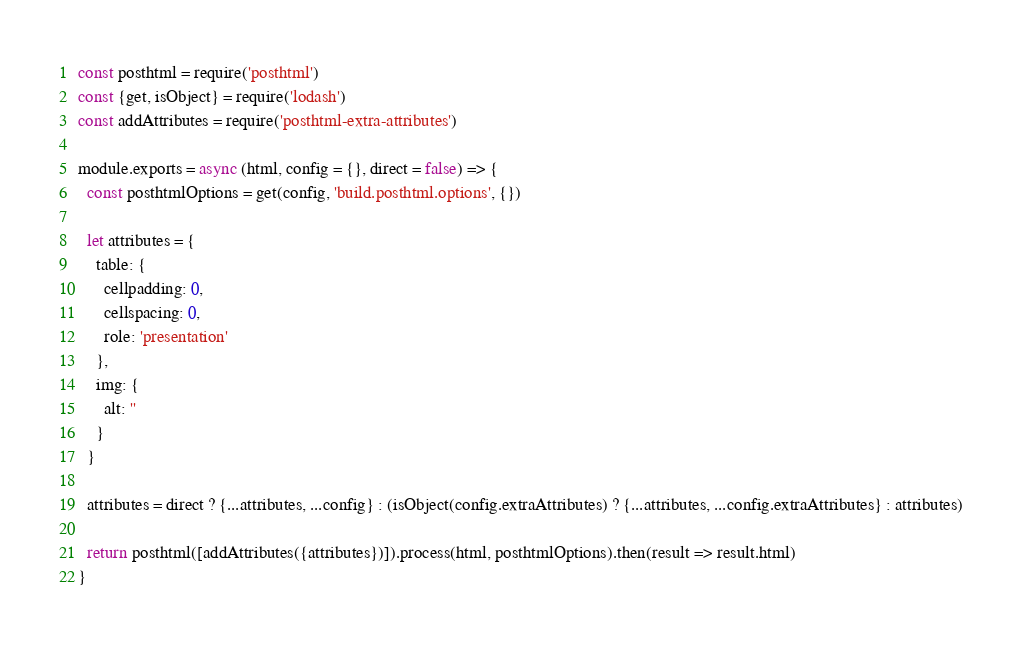<code> <loc_0><loc_0><loc_500><loc_500><_JavaScript_>const posthtml = require('posthtml')
const {get, isObject} = require('lodash')
const addAttributes = require('posthtml-extra-attributes')

module.exports = async (html, config = {}, direct = false) => {
  const posthtmlOptions = get(config, 'build.posthtml.options', {})

  let attributes = {
    table: {
      cellpadding: 0,
      cellspacing: 0,
      role: 'presentation'
    },
    img: {
      alt: ''
    }
  }

  attributes = direct ? {...attributes, ...config} : (isObject(config.extraAttributes) ? {...attributes, ...config.extraAttributes} : attributes)

  return posthtml([addAttributes({attributes})]).process(html, posthtmlOptions).then(result => result.html)
}
</code> 